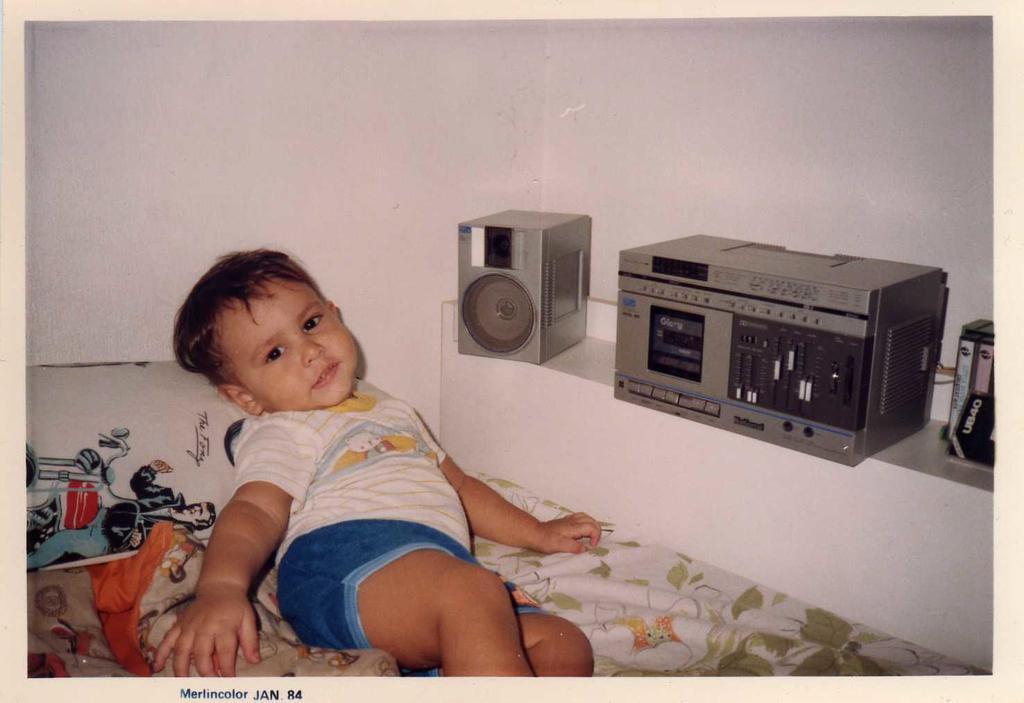Can you describe this image briefly? In this image we can see a kid lying on the bed and on the right side there is a music player and a speaker on the shelf. 